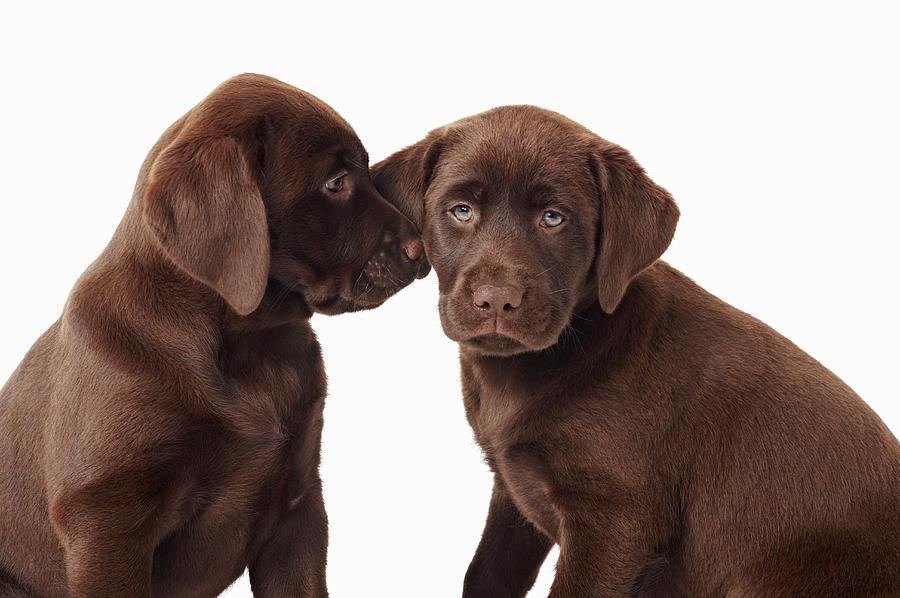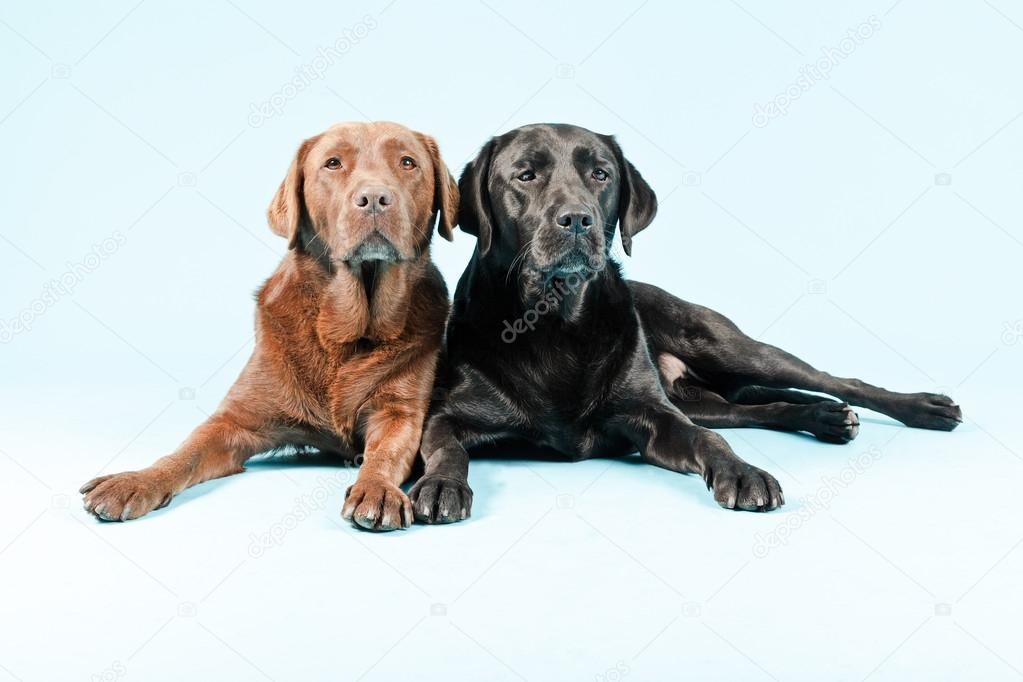The first image is the image on the left, the second image is the image on the right. Given the left and right images, does the statement "none of the dogs in the image pair have collars on" hold true? Answer yes or no. Yes. The first image is the image on the left, the second image is the image on the right. Examine the images to the left and right. Is the description "Two dogs are sitting and two dogs are lying down." accurate? Answer yes or no. Yes. 